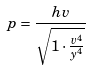<formula> <loc_0><loc_0><loc_500><loc_500>p = \frac { h v } { \sqrt { 1 \cdot \frac { v ^ { 4 } } { y ^ { 4 } } } }</formula> 